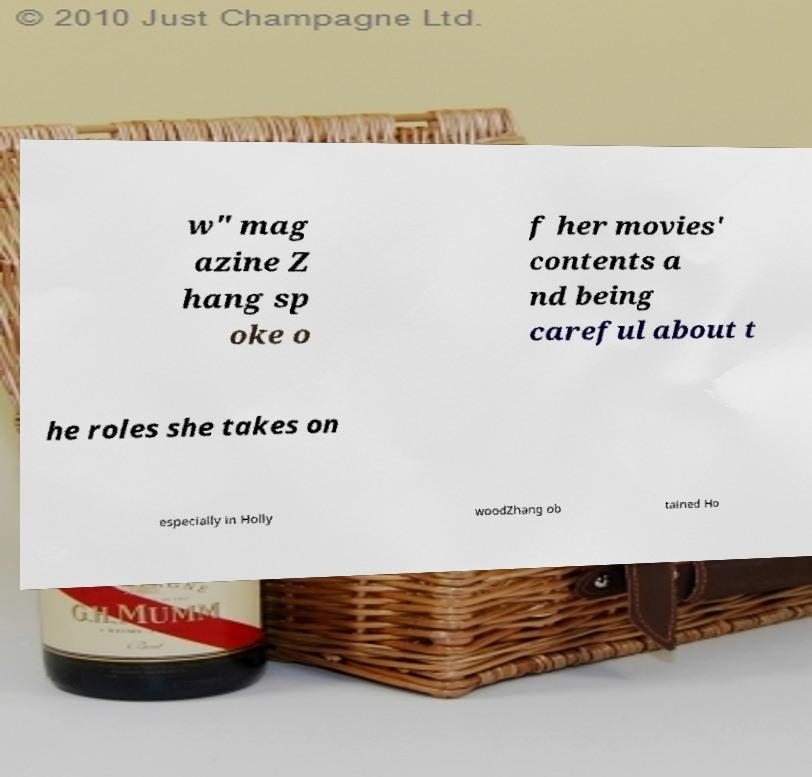There's text embedded in this image that I need extracted. Can you transcribe it verbatim? w" mag azine Z hang sp oke o f her movies' contents a nd being careful about t he roles she takes on especially in Holly woodZhang ob tained Ho 